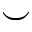Convert formula to latex. <formula><loc_0><loc_0><loc_500><loc_500>\smile</formula> 